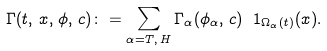<formula> <loc_0><loc_0><loc_500><loc_500>\Gamma ( t , \, x , \, \phi , \, c ) \colon = \sum _ { \alpha = T , \, H } \Gamma _ { \alpha } ( \phi _ { \alpha } , \, c ) \ 1 _ { \Omega _ { \alpha } ( t ) } ( x ) .</formula> 